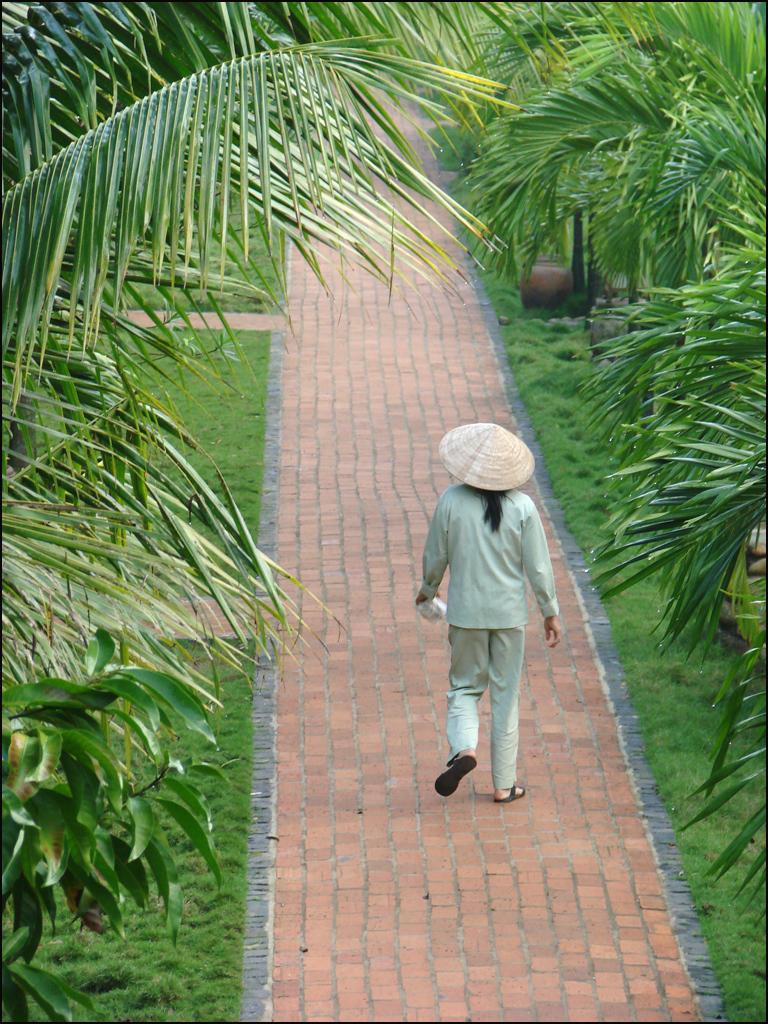Could you give a brief overview of what you see in this image? In the center of the image, we can see a person walking and wearing hat and holding an object. In the background, there are trees and at the bottom, there is sidewalk. 